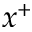Convert formula to latex. <formula><loc_0><loc_0><loc_500><loc_500>x ^ { + }</formula> 